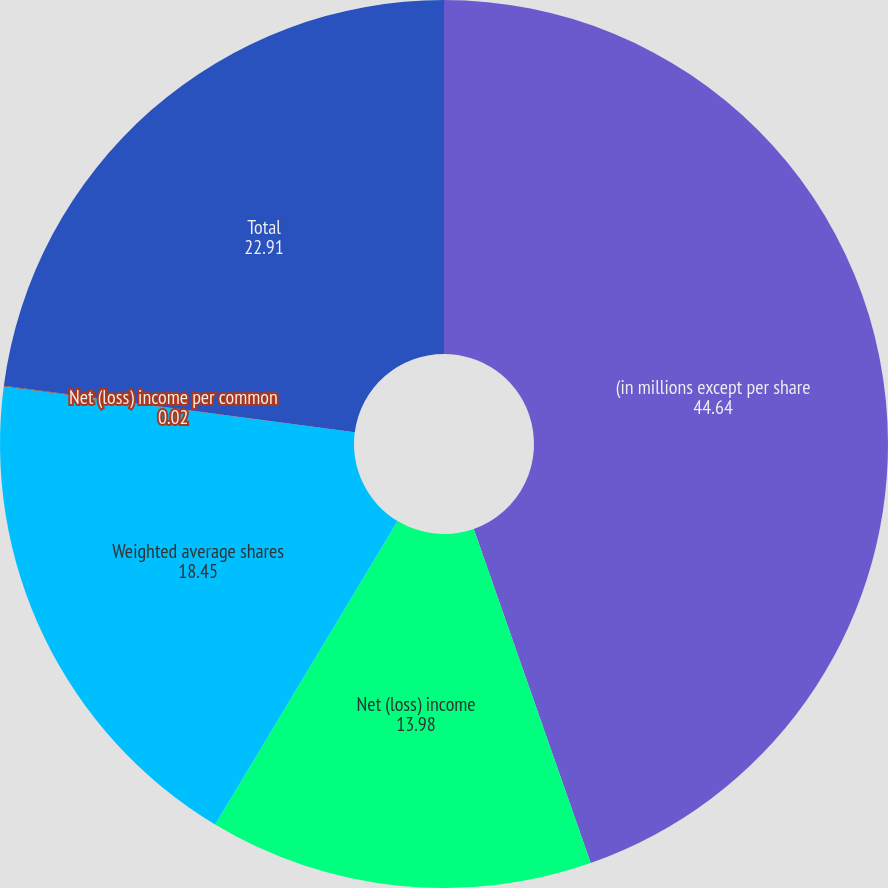Convert chart to OTSL. <chart><loc_0><loc_0><loc_500><loc_500><pie_chart><fcel>(in millions except per share<fcel>Net (loss) income<fcel>Weighted average shares<fcel>Net (loss) income per common<fcel>Total<nl><fcel>44.64%<fcel>13.98%<fcel>18.45%<fcel>0.02%<fcel>22.91%<nl></chart> 